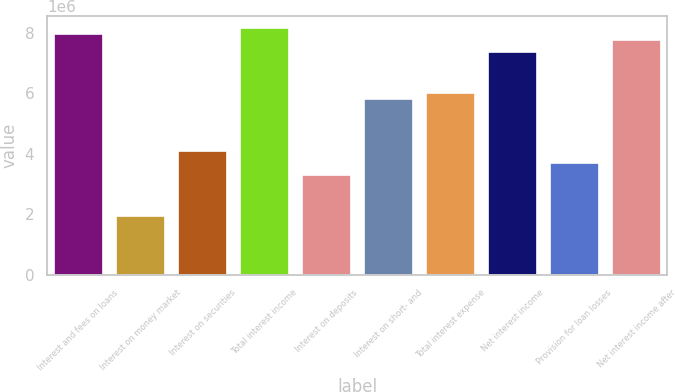Convert chart to OTSL. <chart><loc_0><loc_0><loc_500><loc_500><bar_chart><fcel>Interest and fees on loans<fcel>Interest on money market<fcel>Interest on securities<fcel>Total interest income<fcel>Interest on deposits<fcel>Interest on short- and<fcel>Total interest expense<fcel>Net interest income<fcel>Provision for loan losses<fcel>Net interest income after<nl><fcel>7.95988e+06<fcel>1.94144e+06<fcel>4.07701e+06<fcel>8.15403e+06<fcel>3.30044e+06<fcel>5.8243e+06<fcel>6.01845e+06<fcel>7.37745e+06<fcel>3.68873e+06<fcel>7.76574e+06<nl></chart> 